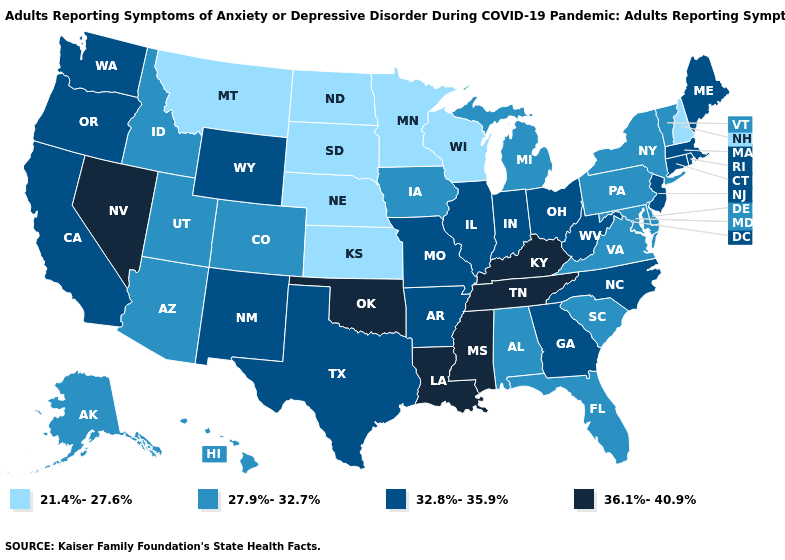Does Oklahoma have the highest value in the South?
Quick response, please. Yes. Is the legend a continuous bar?
Be succinct. No. Name the states that have a value in the range 32.8%-35.9%?
Short answer required. Arkansas, California, Connecticut, Georgia, Illinois, Indiana, Maine, Massachusetts, Missouri, New Jersey, New Mexico, North Carolina, Ohio, Oregon, Rhode Island, Texas, Washington, West Virginia, Wyoming. Is the legend a continuous bar?
Concise answer only. No. Which states have the highest value in the USA?
Keep it brief. Kentucky, Louisiana, Mississippi, Nevada, Oklahoma, Tennessee. Among the states that border Delaware , does New Jersey have the highest value?
Quick response, please. Yes. Does the map have missing data?
Concise answer only. No. Does Kentucky have the same value as Tennessee?
Quick response, please. Yes. Which states have the lowest value in the West?
Write a very short answer. Montana. Does South Dakota have the highest value in the USA?
Quick response, please. No. Name the states that have a value in the range 36.1%-40.9%?
Quick response, please. Kentucky, Louisiana, Mississippi, Nevada, Oklahoma, Tennessee. Does Maryland have the lowest value in the USA?
Keep it brief. No. Name the states that have a value in the range 32.8%-35.9%?
Answer briefly. Arkansas, California, Connecticut, Georgia, Illinois, Indiana, Maine, Massachusetts, Missouri, New Jersey, New Mexico, North Carolina, Ohio, Oregon, Rhode Island, Texas, Washington, West Virginia, Wyoming. Does Mississippi have the highest value in the USA?
Quick response, please. Yes. Name the states that have a value in the range 27.9%-32.7%?
Be succinct. Alabama, Alaska, Arizona, Colorado, Delaware, Florida, Hawaii, Idaho, Iowa, Maryland, Michigan, New York, Pennsylvania, South Carolina, Utah, Vermont, Virginia. 